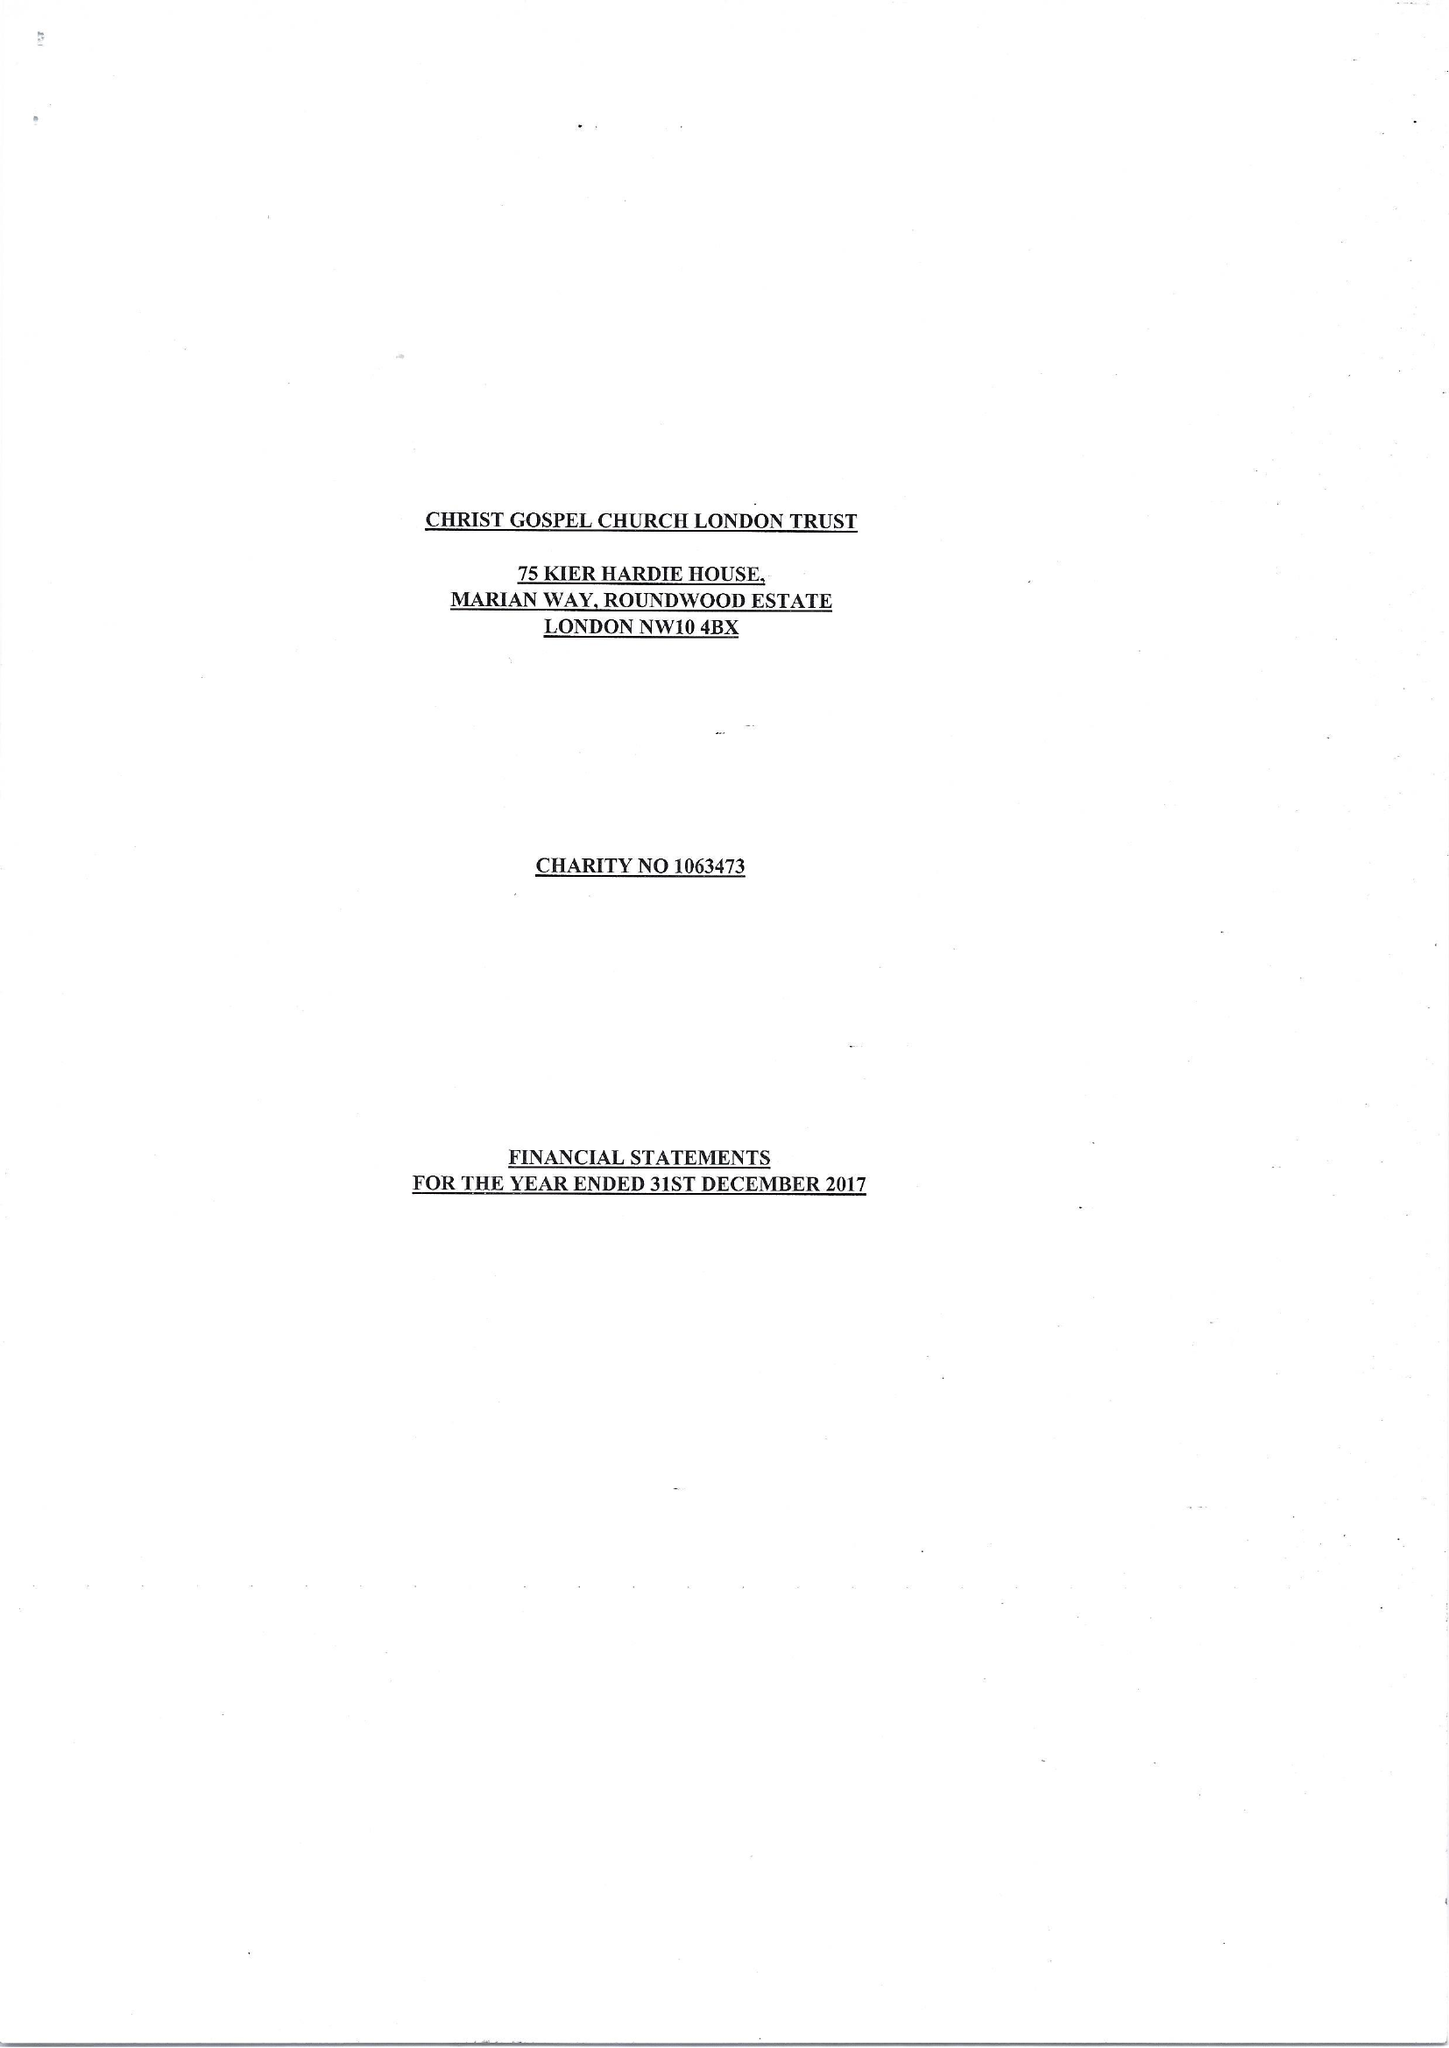What is the value for the charity_number?
Answer the question using a single word or phrase. 1063473 